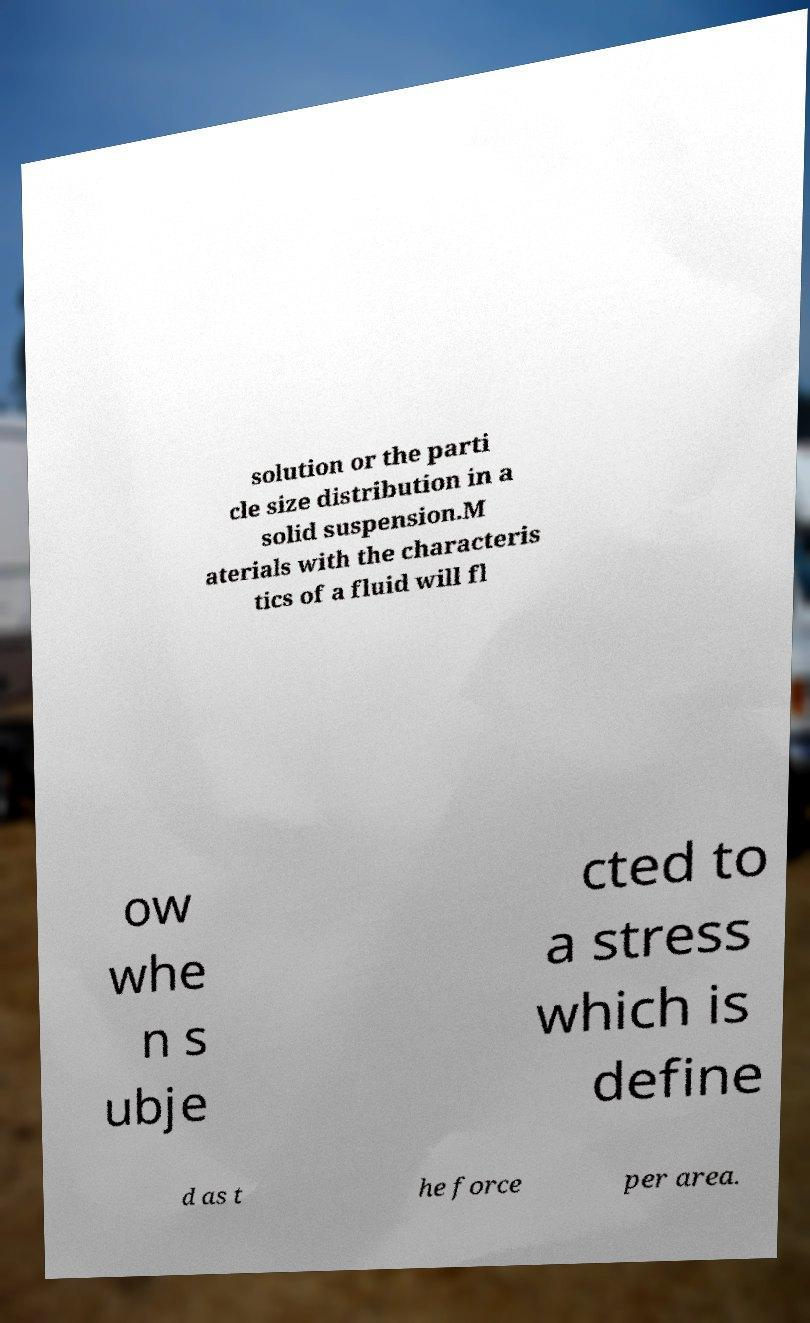Can you accurately transcribe the text from the provided image for me? solution or the parti cle size distribution in a solid suspension.M aterials with the characteris tics of a fluid will fl ow whe n s ubje cted to a stress which is define d as t he force per area. 